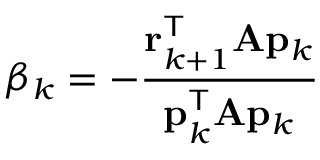<formula> <loc_0><loc_0><loc_500><loc_500>\beta _ { k } = - { \frac { r _ { k + 1 } ^ { T } A p _ { k } } { p _ { k } ^ { T } A p _ { k } } }</formula> 